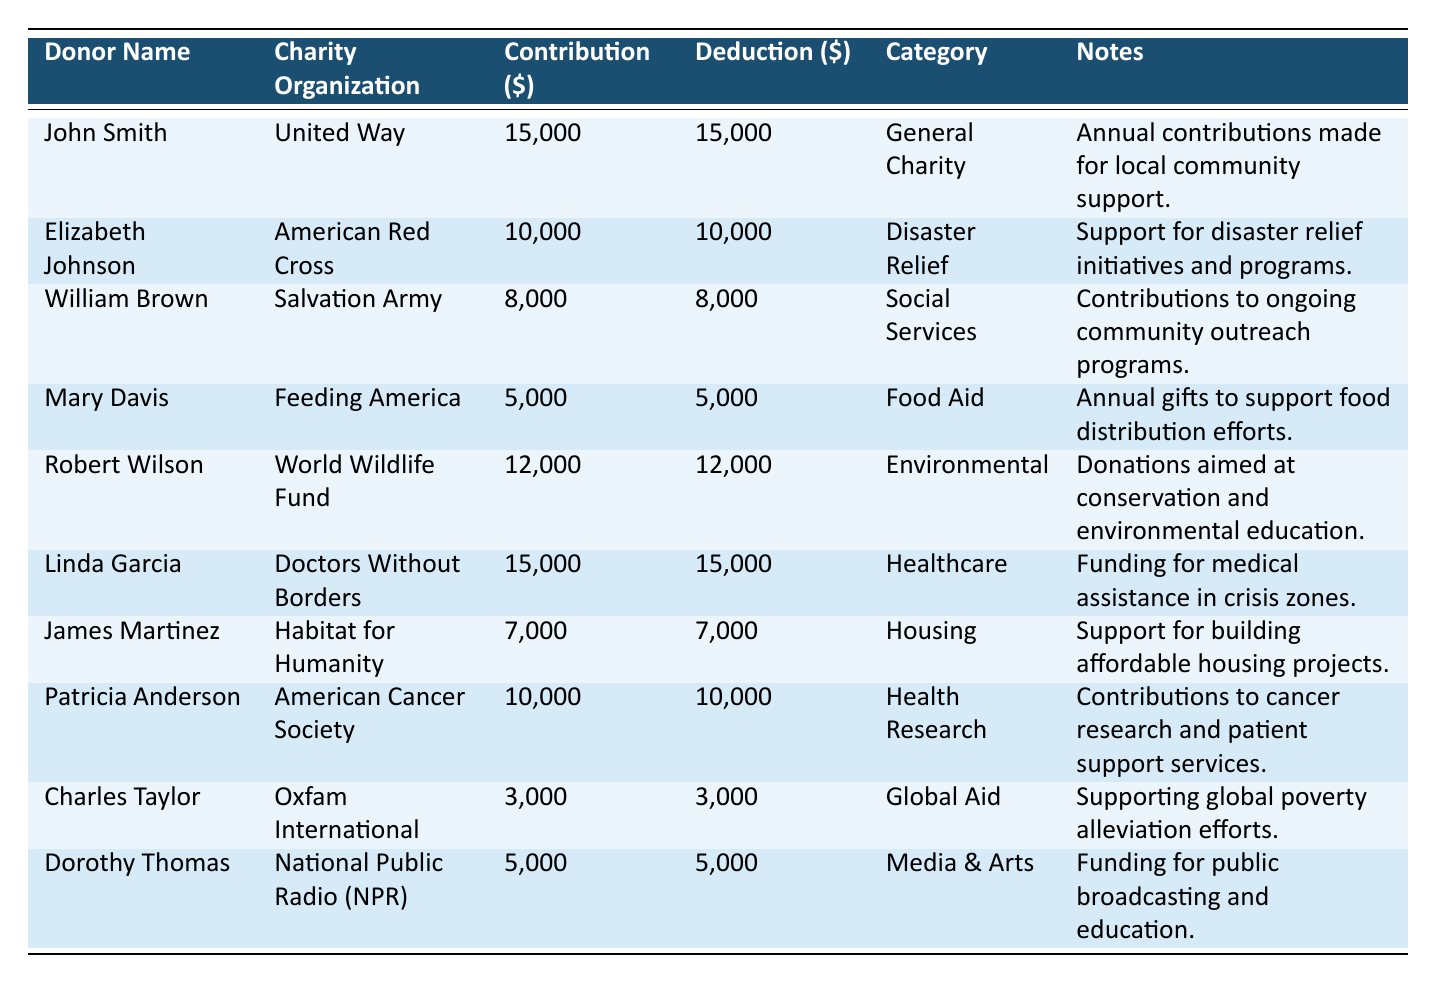What is the total amount of contributions made by all donors? To find the total contributions, sum up the contribution amounts from each donor: 15000 + 10000 + 8000 + 5000 + 12000 + 15000 + 7000 + 10000 + 3000 + 5000 = 100000.
Answer: 100000 Who donated to the "Healthcare" category? According to the table, Linda Garcia is the only donor associated with the "Healthcare" category, donating 15000.
Answer: Linda Garcia How many donors made contributions greater than 10000? By reviewing the contribution amounts in the table, the donors who contributed more than 10000 are John Smith (15000), Robert Wilson (12000), and Linda Garcia (15000). This gives us a total of 3 donors.
Answer: 3 What is the average contribution amount across all donors? Calculate the average contribution by taking the total contributions (100000) and dividing it by the number of donors (10). Average = 100000 / 10 = 10000.
Answer: 10000 Did any donor contribute less than 5000? Look at the contribution amounts; Charles Taylor (3000) is the only donor who contributed less than 5000. Therefore, the answer is yes.
Answer: Yes Which organization received the largest single contribution? Examine the contribution amounts; the largest single contribution recorded is 15000 made to both United Way and Doctors Without Borders.
Answer: United Way and Doctors Without Borders What is the total deduction amount for donors who contributed to "Food Aid"? Mary Davis contributed 5000 to "Food Aid," so the total deduction for that category is also 5000 since the deduction amount equals the contribution amount.
Answer: 5000 How many different categories are represented in the table? By reviewing the categories listed: General Charity, Disaster Relief, Social Services, Food Aid, Environmental, Healthcare, Housing, Health Research, Global Aid, Media & Arts, there are ten unique categories.
Answer: 10 Which donor contributed to both "Social Services" and "Housing"? Review the contributions related to those categories. William Brown contributed to "Social Services," and James Martinez to "Housing." Neither contributed to both, so the answer is no donor contributed to both.
Answer: None What charitable organization received contributions from the largest number of donors? Analyzing the data, each organization received contributions from one donor only. Therefore, there is no organization that received contributions from multiple donors.
Answer: None 